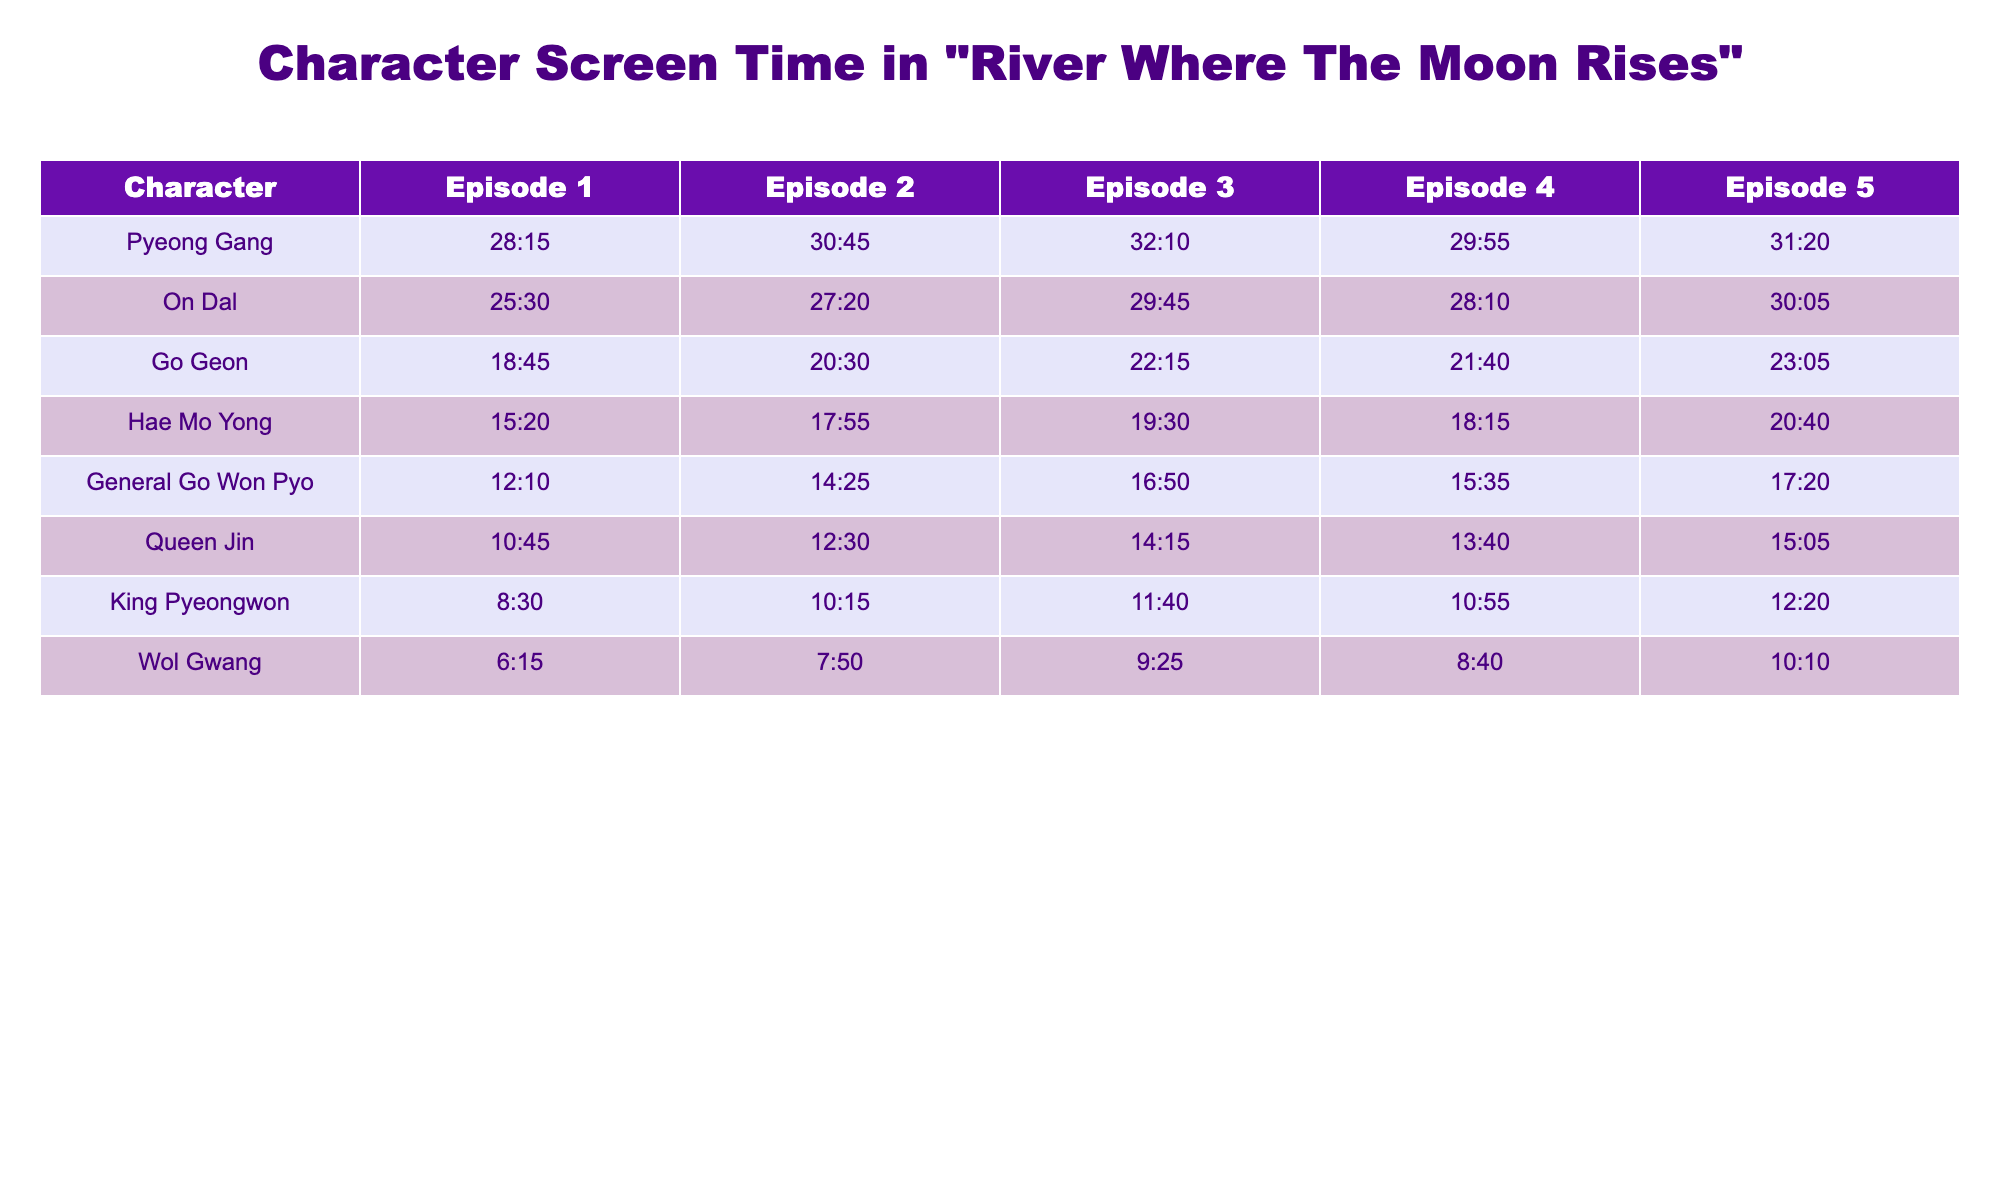What is the screen time of Pyeong Gang in Episode 3? In the table, I can find the screen time for Pyeong Gang under Episode 3, which shows 32:10 as the value.
Answer: 32:10 Which character has the least screen time in Episode 1? In Episode 1, I can check the screen time for all characters. The least time is listed for King Pyeongwon, which is 8:30.
Answer: King Pyeongwon What is the total screen time for On Dal across all episodes? First, I’ll convert the screen time for On Dal from all episodes to seconds: Episode 1: 1530 seconds, Episode 2: 1640 seconds, Episode 3: 1785 seconds, Episode 4: 1690 seconds, Episode 5: 1805 seconds. Adding these gives a total of 1530 + 1640 + 1785 + 1690 + 1805 = 10450 seconds, which converts back to 174 minutes and 10 seconds.
Answer: 174:10 Which character has the highest screen time average across the episodes? To determine this, I’ll calculate the average screen time for each character by summing their screen time over the 5 episodes and dividing by 5. The highest average comes from Pyeong Gang at (28:15 + 30:45 + 32:10 + 29:55 + 31:20) / 5 = 30:00. Thus, Pyeong Gang has the highest average.
Answer: Pyeong Gang Did Go Geon have more screen time in Episode 2 than Hae Mo Yong in Episode 1? For Go Geon, Episode 2 shows 20:30 and for Hae Mo Yong, Episode 1 shows 15:20. Since 20:30 is greater than 15:20, the answer is yes.
Answer: Yes What is the difference in screen time between General Go Won Pyo in Episode 5 and Queen Jin in Episode 4? The screen time for General Go Won Pyo in Episode 5 is 17:20 and for Queen Jin in Episode 4 it is 13:40. First, convert these times to seconds: General Go Won Pyo: 1040 seconds, Queen Jin: 820 seconds. The difference is 1040 - 820 = 220 seconds, which converts back to 3 minutes and 40 seconds.
Answer: 3:40 Which character appears the most in Episode 4? I will check the screen times for all characters in Episode 4. The character with the greatest screen time is Pyeong Gang with 29:55.
Answer: Pyeong Gang What is the screen time trend for Hae Mo Yong over the five episodes? I will examine the values: 15:20, 17:55, 19:30, 18:15, 20:40. The trend shows a general increase, with a slight decrease between Episodes 3 and 4 but overall moving upwards.
Answer: Increasing trend 